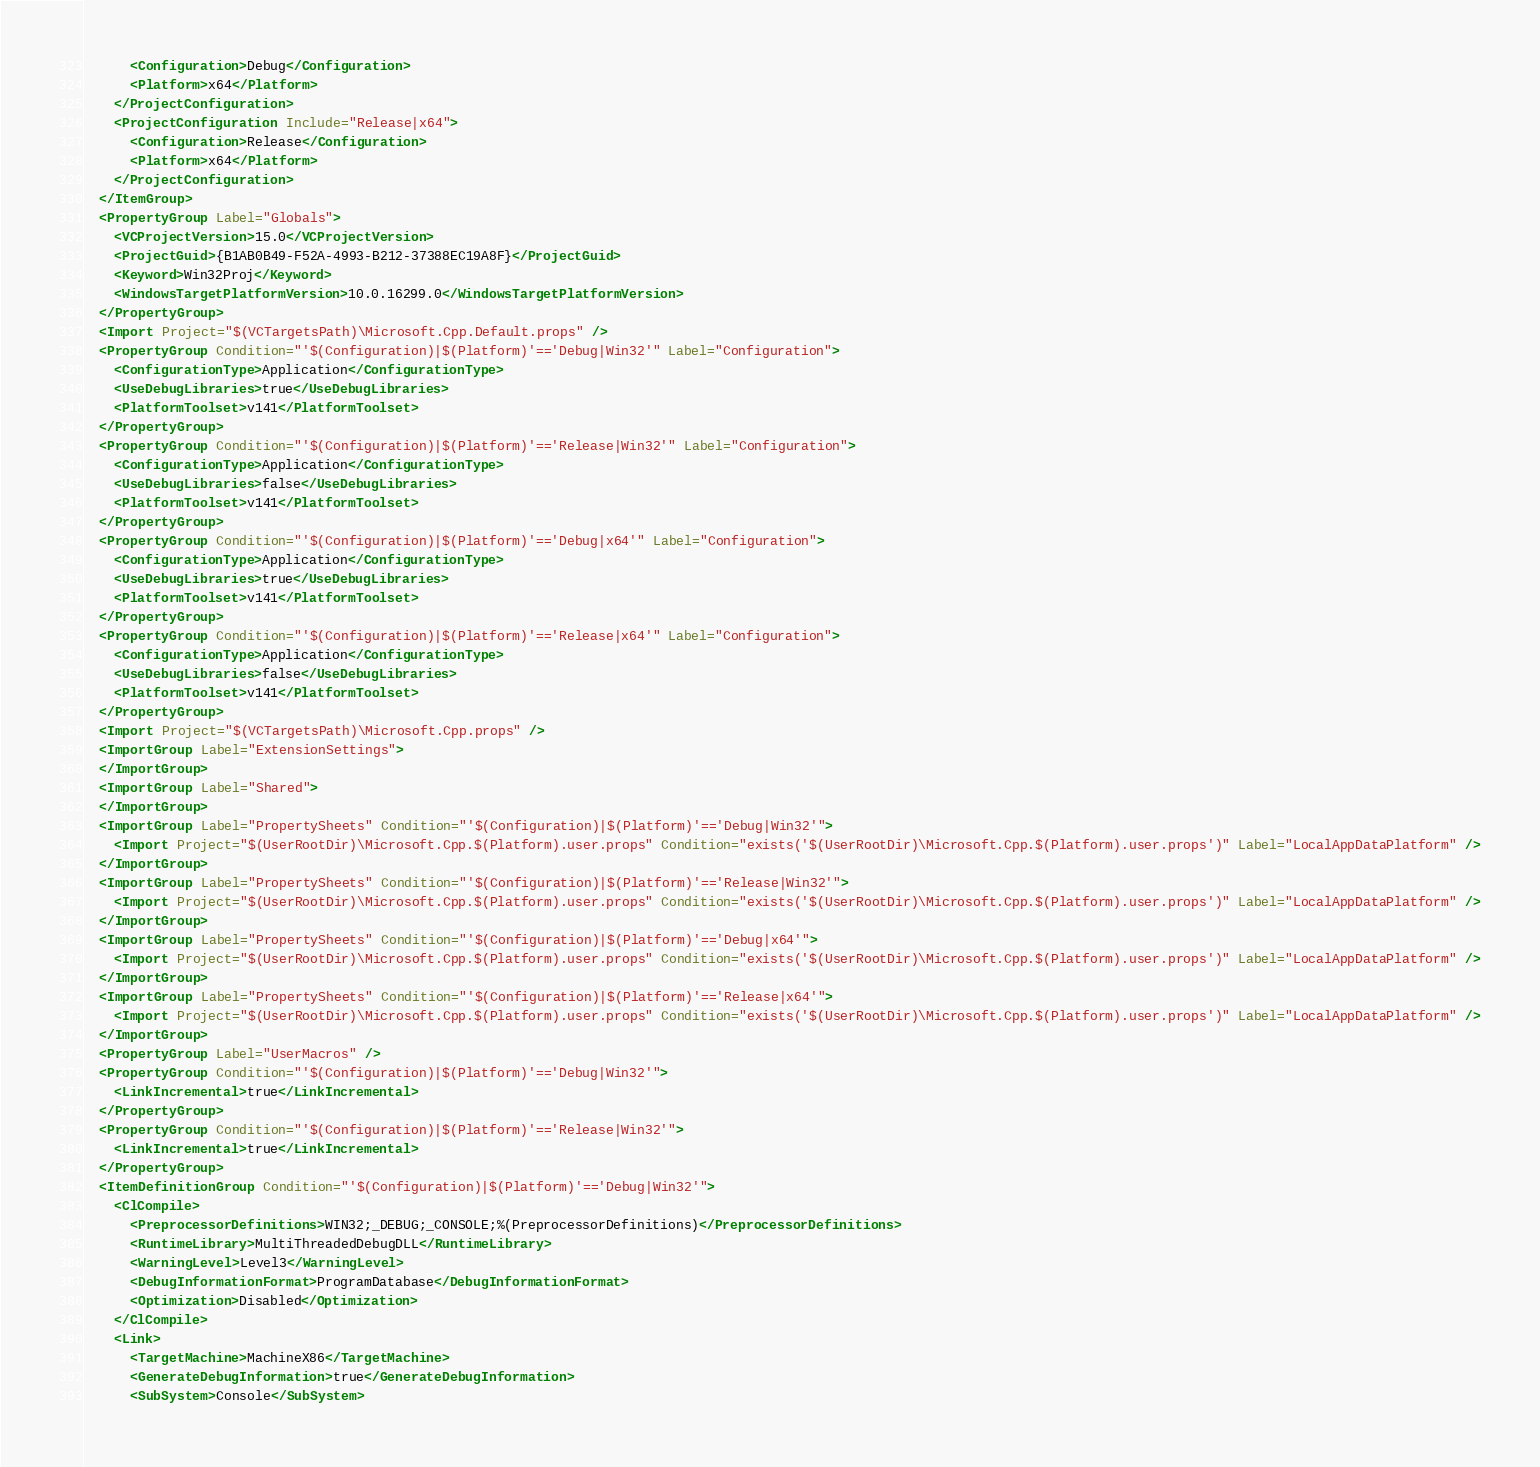<code> <loc_0><loc_0><loc_500><loc_500><_XML_>      <Configuration>Debug</Configuration>
      <Platform>x64</Platform>
    </ProjectConfiguration>
    <ProjectConfiguration Include="Release|x64">
      <Configuration>Release</Configuration>
      <Platform>x64</Platform>
    </ProjectConfiguration>
  </ItemGroup>
  <PropertyGroup Label="Globals">
    <VCProjectVersion>15.0</VCProjectVersion>
    <ProjectGuid>{B1AB0B49-F52A-4993-B212-37388EC19A8F}</ProjectGuid>
    <Keyword>Win32Proj</Keyword>
    <WindowsTargetPlatformVersion>10.0.16299.0</WindowsTargetPlatformVersion>
  </PropertyGroup>
  <Import Project="$(VCTargetsPath)\Microsoft.Cpp.Default.props" />
  <PropertyGroup Condition="'$(Configuration)|$(Platform)'=='Debug|Win32'" Label="Configuration">
    <ConfigurationType>Application</ConfigurationType>
    <UseDebugLibraries>true</UseDebugLibraries>
    <PlatformToolset>v141</PlatformToolset>
  </PropertyGroup>
  <PropertyGroup Condition="'$(Configuration)|$(Platform)'=='Release|Win32'" Label="Configuration">
    <ConfigurationType>Application</ConfigurationType>
    <UseDebugLibraries>false</UseDebugLibraries>
    <PlatformToolset>v141</PlatformToolset>
  </PropertyGroup>
  <PropertyGroup Condition="'$(Configuration)|$(Platform)'=='Debug|x64'" Label="Configuration">
    <ConfigurationType>Application</ConfigurationType>
    <UseDebugLibraries>true</UseDebugLibraries>
    <PlatformToolset>v141</PlatformToolset>
  </PropertyGroup>
  <PropertyGroup Condition="'$(Configuration)|$(Platform)'=='Release|x64'" Label="Configuration">
    <ConfigurationType>Application</ConfigurationType>
    <UseDebugLibraries>false</UseDebugLibraries>
    <PlatformToolset>v141</PlatformToolset>
  </PropertyGroup>
  <Import Project="$(VCTargetsPath)\Microsoft.Cpp.props" />
  <ImportGroup Label="ExtensionSettings">
  </ImportGroup>
  <ImportGroup Label="Shared">
  </ImportGroup>
  <ImportGroup Label="PropertySheets" Condition="'$(Configuration)|$(Platform)'=='Debug|Win32'">
    <Import Project="$(UserRootDir)\Microsoft.Cpp.$(Platform).user.props" Condition="exists('$(UserRootDir)\Microsoft.Cpp.$(Platform).user.props')" Label="LocalAppDataPlatform" />
  </ImportGroup>
  <ImportGroup Label="PropertySheets" Condition="'$(Configuration)|$(Platform)'=='Release|Win32'">
    <Import Project="$(UserRootDir)\Microsoft.Cpp.$(Platform).user.props" Condition="exists('$(UserRootDir)\Microsoft.Cpp.$(Platform).user.props')" Label="LocalAppDataPlatform" />
  </ImportGroup>
  <ImportGroup Label="PropertySheets" Condition="'$(Configuration)|$(Platform)'=='Debug|x64'">
    <Import Project="$(UserRootDir)\Microsoft.Cpp.$(Platform).user.props" Condition="exists('$(UserRootDir)\Microsoft.Cpp.$(Platform).user.props')" Label="LocalAppDataPlatform" />
  </ImportGroup>
  <ImportGroup Label="PropertySheets" Condition="'$(Configuration)|$(Platform)'=='Release|x64'">
    <Import Project="$(UserRootDir)\Microsoft.Cpp.$(Platform).user.props" Condition="exists('$(UserRootDir)\Microsoft.Cpp.$(Platform).user.props')" Label="LocalAppDataPlatform" />
  </ImportGroup>
  <PropertyGroup Label="UserMacros" />
  <PropertyGroup Condition="'$(Configuration)|$(Platform)'=='Debug|Win32'">
    <LinkIncremental>true</LinkIncremental>
  </PropertyGroup>
  <PropertyGroup Condition="'$(Configuration)|$(Platform)'=='Release|Win32'">
    <LinkIncremental>true</LinkIncremental>
  </PropertyGroup>
  <ItemDefinitionGroup Condition="'$(Configuration)|$(Platform)'=='Debug|Win32'">
    <ClCompile>
      <PreprocessorDefinitions>WIN32;_DEBUG;_CONSOLE;%(PreprocessorDefinitions)</PreprocessorDefinitions>
      <RuntimeLibrary>MultiThreadedDebugDLL</RuntimeLibrary>
      <WarningLevel>Level3</WarningLevel>
      <DebugInformationFormat>ProgramDatabase</DebugInformationFormat>
      <Optimization>Disabled</Optimization>
    </ClCompile>
    <Link>
      <TargetMachine>MachineX86</TargetMachine>
      <GenerateDebugInformation>true</GenerateDebugInformation>
      <SubSystem>Console</SubSystem></code> 